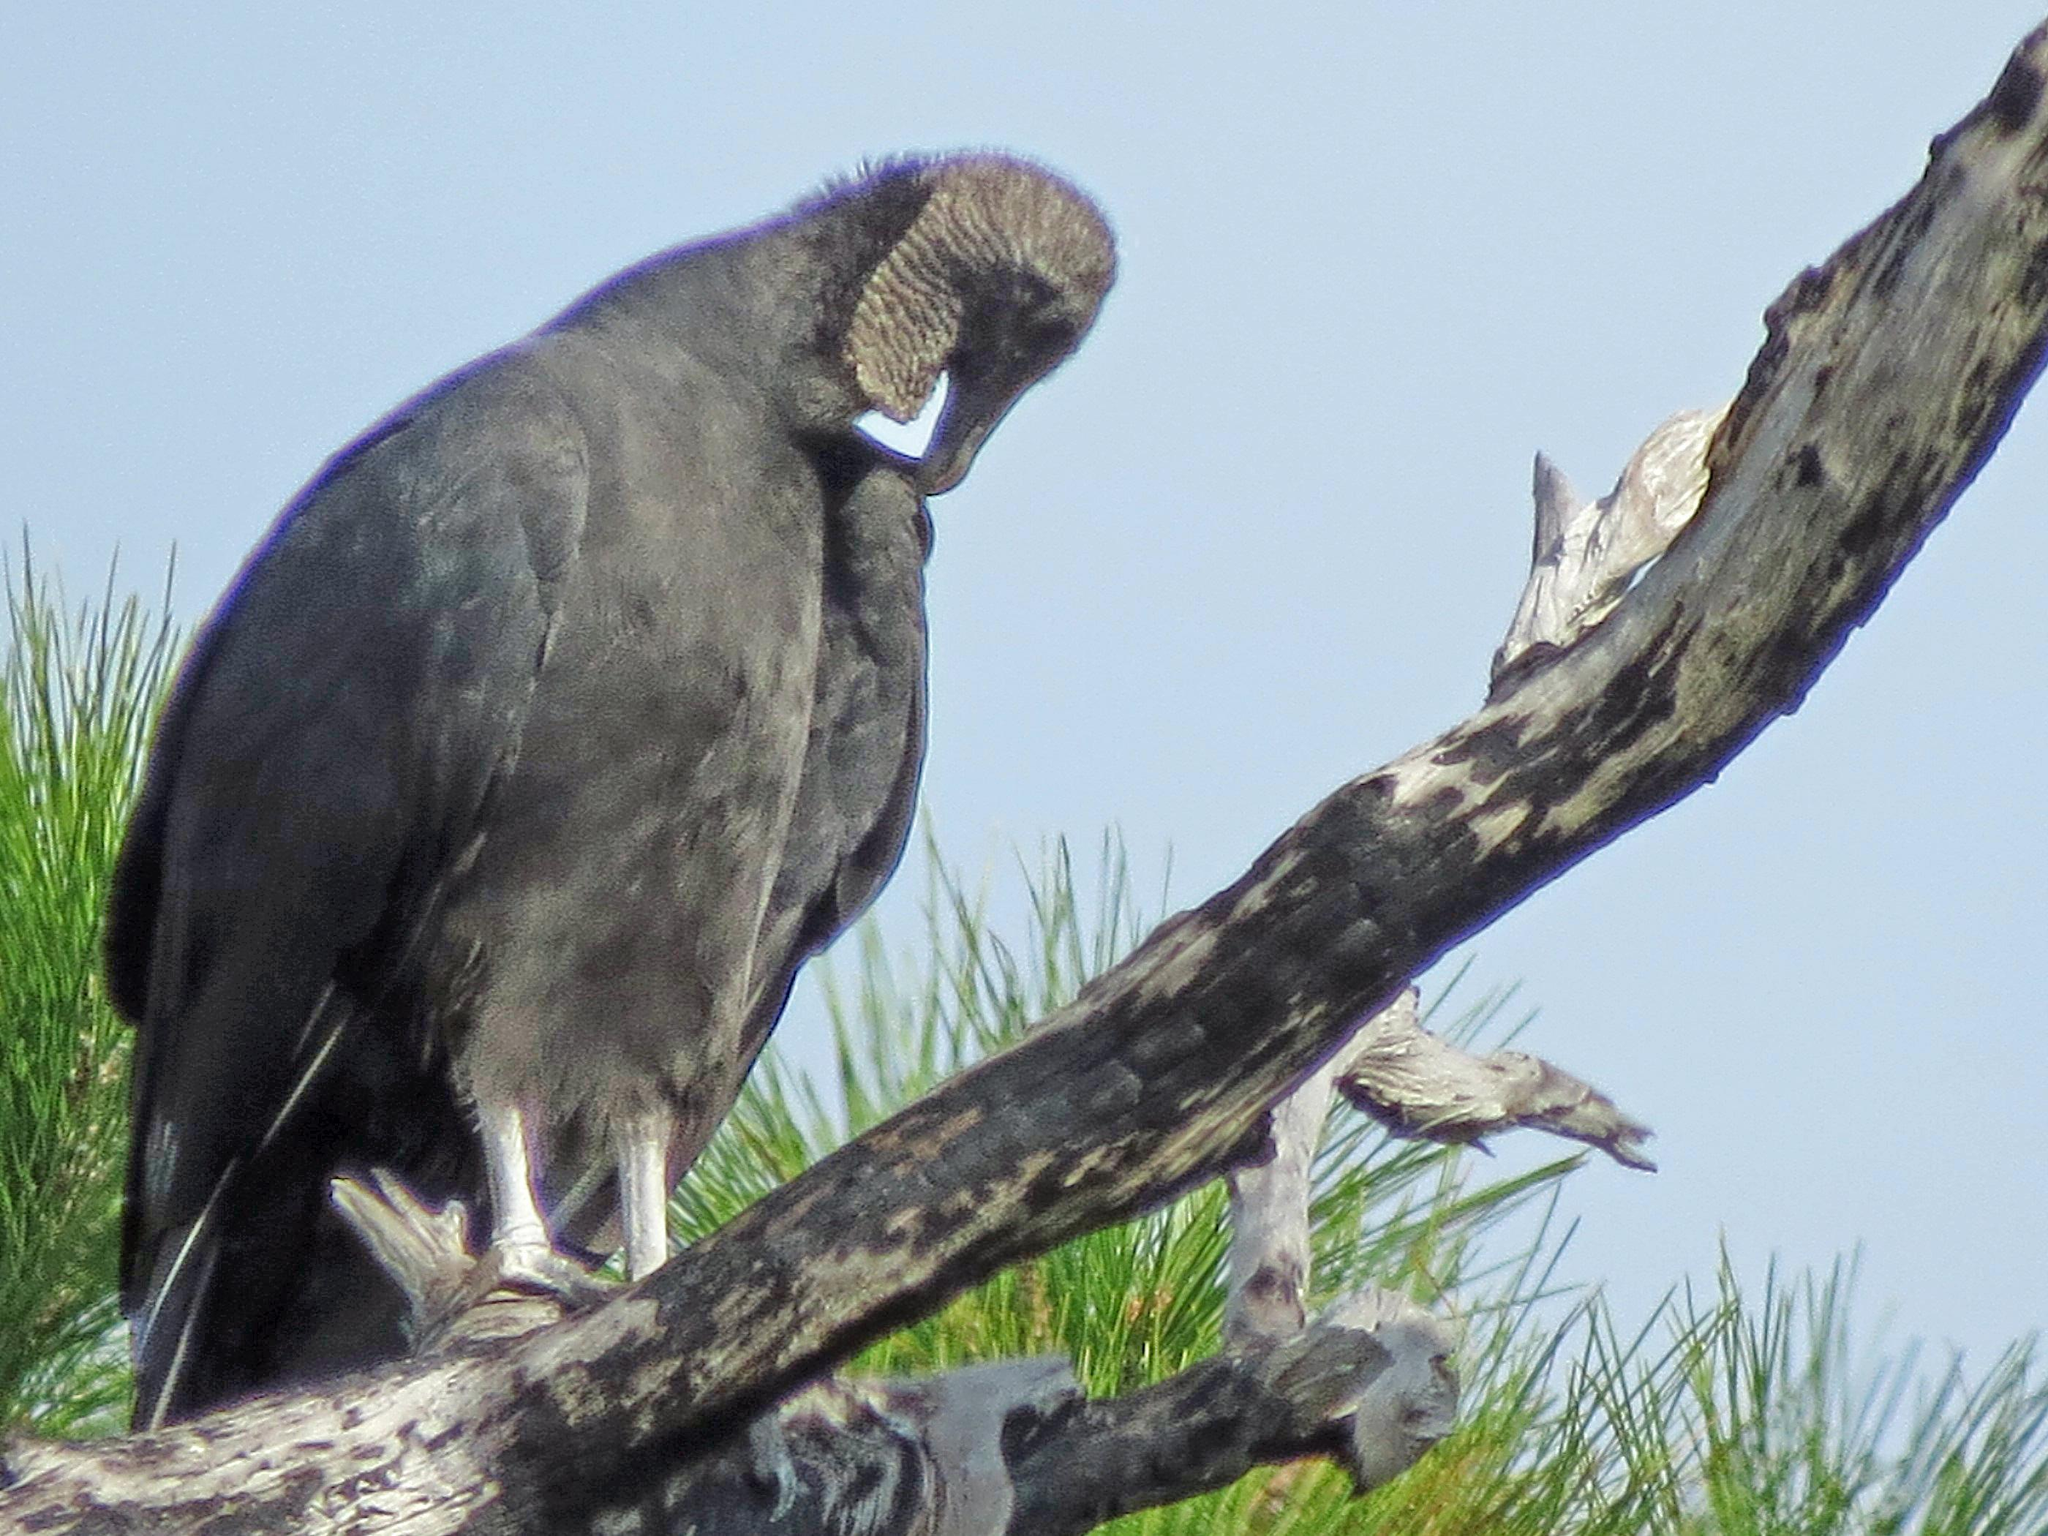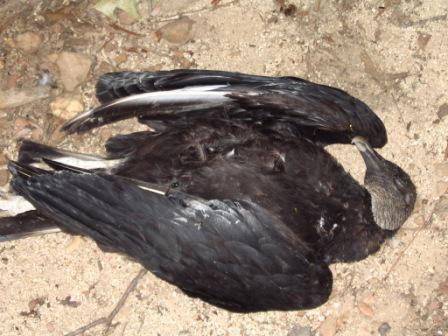The first image is the image on the left, the second image is the image on the right. Analyze the images presented: Is the assertion "In one of the images the bird is perched on a large branch." valid? Answer yes or no. Yes. The first image is the image on the left, the second image is the image on the right. For the images shown, is this caption "One of the birds is perched in a tree branch." true? Answer yes or no. Yes. 